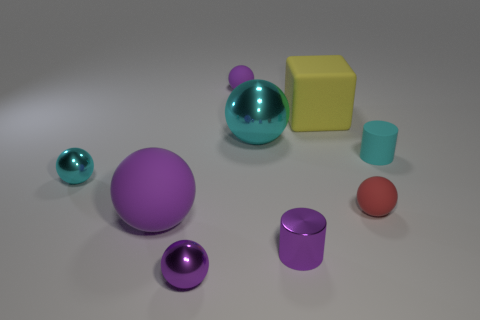Is there anything else of the same color as the metallic cylinder?
Make the answer very short. Yes. There is a rubber sphere that is on the right side of the small purple cylinder; what color is it?
Keep it short and to the point. Red. Does the rubber thing behind the big yellow cube have the same color as the large rubber sphere?
Provide a short and direct response. Yes. What material is the large purple thing that is the same shape as the big cyan object?
Give a very brief answer. Rubber. What number of purple shiny things have the same size as the red sphere?
Offer a very short reply. 2. There is a tiny red rubber thing; what shape is it?
Ensure brevity in your answer.  Sphere. There is a rubber object that is both behind the rubber cylinder and to the left of the yellow rubber thing; what is its size?
Ensure brevity in your answer.  Small. What is the material of the cyan ball that is left of the small purple rubber ball?
Ensure brevity in your answer.  Metal. Does the big rubber block have the same color as the sphere that is left of the big purple matte thing?
Your answer should be compact. No. What number of things are either purple objects to the right of the large metal ball or purple rubber objects in front of the small cyan rubber cylinder?
Provide a short and direct response. 2. 